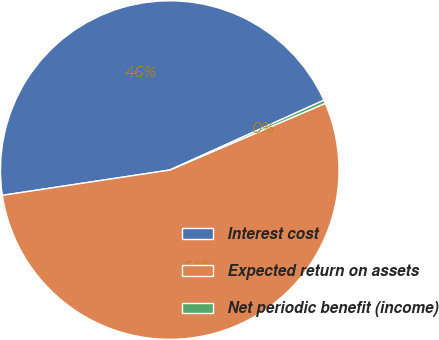<chart> <loc_0><loc_0><loc_500><loc_500><pie_chart><fcel>Interest cost<fcel>Expected return on assets<fcel>Net periodic benefit (income)<nl><fcel>45.61%<fcel>54.06%<fcel>0.32%<nl></chart> 